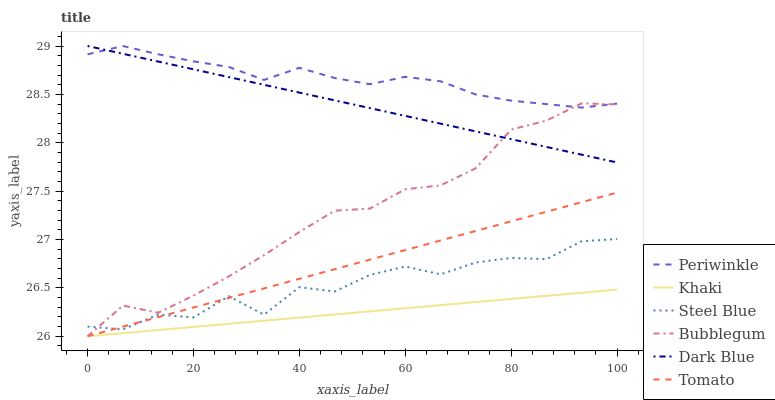Does Khaki have the minimum area under the curve?
Answer yes or no. Yes. Does Periwinkle have the maximum area under the curve?
Answer yes or no. Yes. Does Steel Blue have the minimum area under the curve?
Answer yes or no. No. Does Steel Blue have the maximum area under the curve?
Answer yes or no. No. Is Dark Blue the smoothest?
Answer yes or no. Yes. Is Steel Blue the roughest?
Answer yes or no. Yes. Is Khaki the smoothest?
Answer yes or no. No. Is Khaki the roughest?
Answer yes or no. No. Does Tomato have the lowest value?
Answer yes or no. Yes. Does Steel Blue have the lowest value?
Answer yes or no. No. Does Periwinkle have the highest value?
Answer yes or no. Yes. Does Steel Blue have the highest value?
Answer yes or no. No. Is Khaki less than Periwinkle?
Answer yes or no. Yes. Is Steel Blue greater than Khaki?
Answer yes or no. Yes. Does Steel Blue intersect Tomato?
Answer yes or no. Yes. Is Steel Blue less than Tomato?
Answer yes or no. No. Is Steel Blue greater than Tomato?
Answer yes or no. No. Does Khaki intersect Periwinkle?
Answer yes or no. No. 